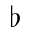Convert formula to latex. <formula><loc_0><loc_0><loc_500><loc_500>\flat</formula> 